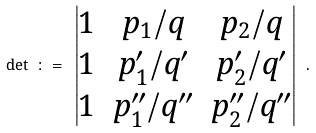<formula> <loc_0><loc_0><loc_500><loc_500>\det \ \colon = \ \begin{vmatrix} 1 & p _ { 1 } / q & p _ { 2 } / q \\ 1 & p ^ { \prime } _ { 1 } / q ^ { \prime } & p ^ { \prime } _ { 2 } / q ^ { \prime } \\ 1 & p ^ { \prime \prime } _ { 1 } / q ^ { \prime \prime } & p ^ { \prime \prime } _ { 2 } / q ^ { \prime \prime } \end{vmatrix} \ .</formula> 